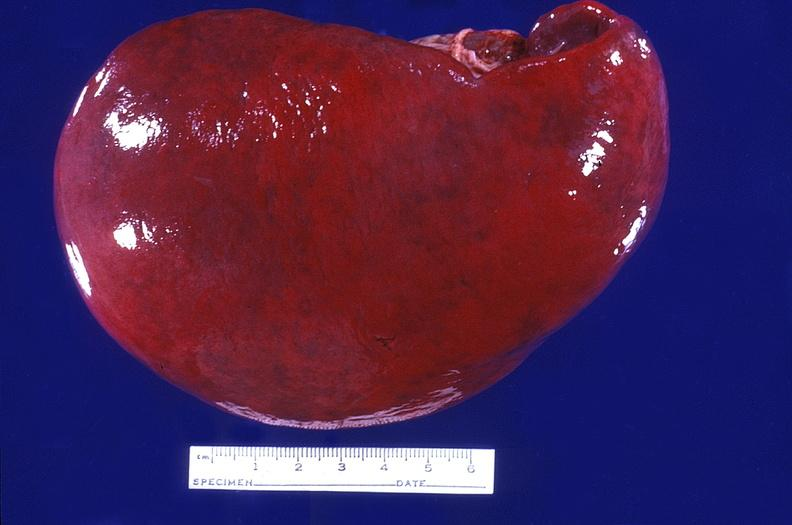does abdomen show spleen, normal?
Answer the question using a single word or phrase. No 